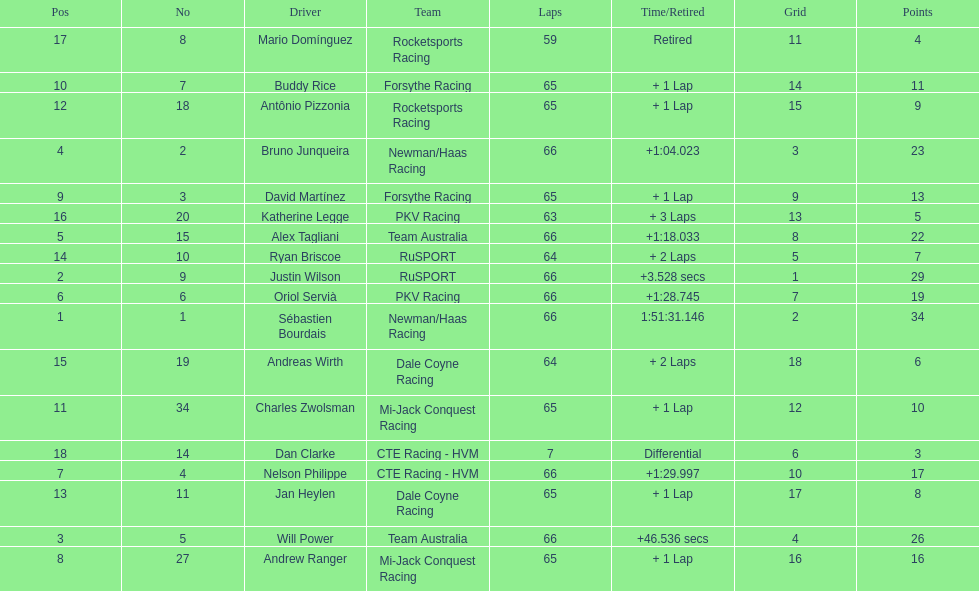What are the names of the drivers who were in position 14 through position 18? Ryan Briscoe, Andreas Wirth, Katherine Legge, Mario Domínguez, Dan Clarke. Of these , which ones didn't finish due to retired or differential? Mario Domínguez, Dan Clarke. Which one of the previous drivers retired? Mario Domínguez. Which of the drivers in question 2 had a differential? Dan Clarke. 